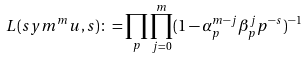<formula> <loc_0><loc_0><loc_500><loc_500>L ( s y m ^ { m } u , s ) \colon = \prod _ { p } \prod ^ { m } _ { j = 0 } ( 1 - \alpha ^ { m - j } _ { p } \beta ^ { j } _ { p } p ^ { - s } ) ^ { - 1 }</formula> 